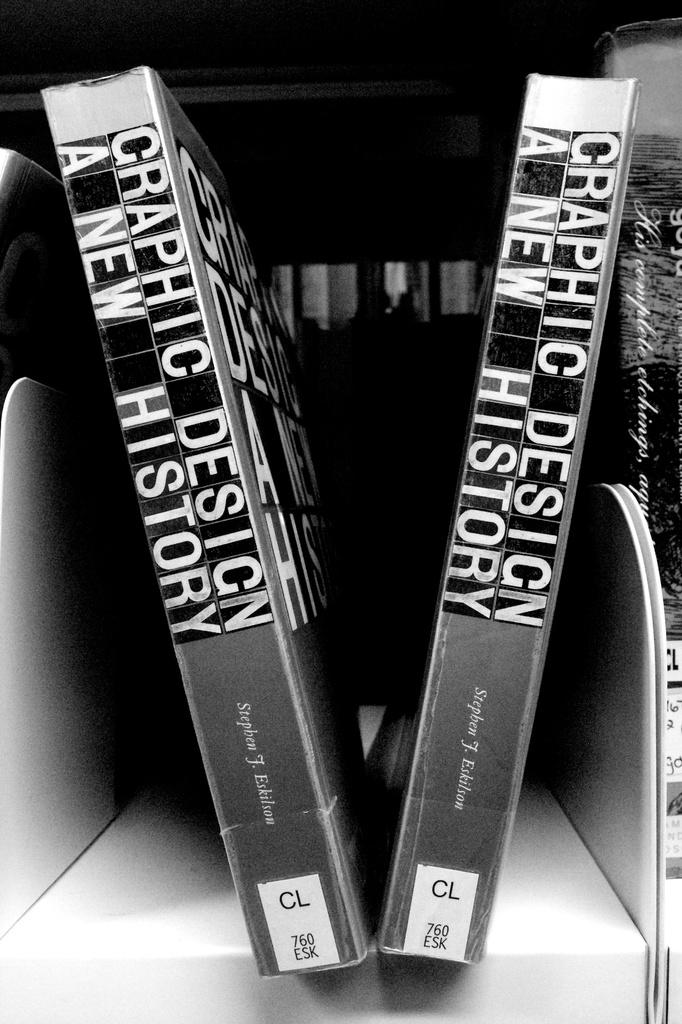<image>
Render a clear and concise summary of the photo. Two books with the same title of Graphic Design A New History sits on a shelf. 